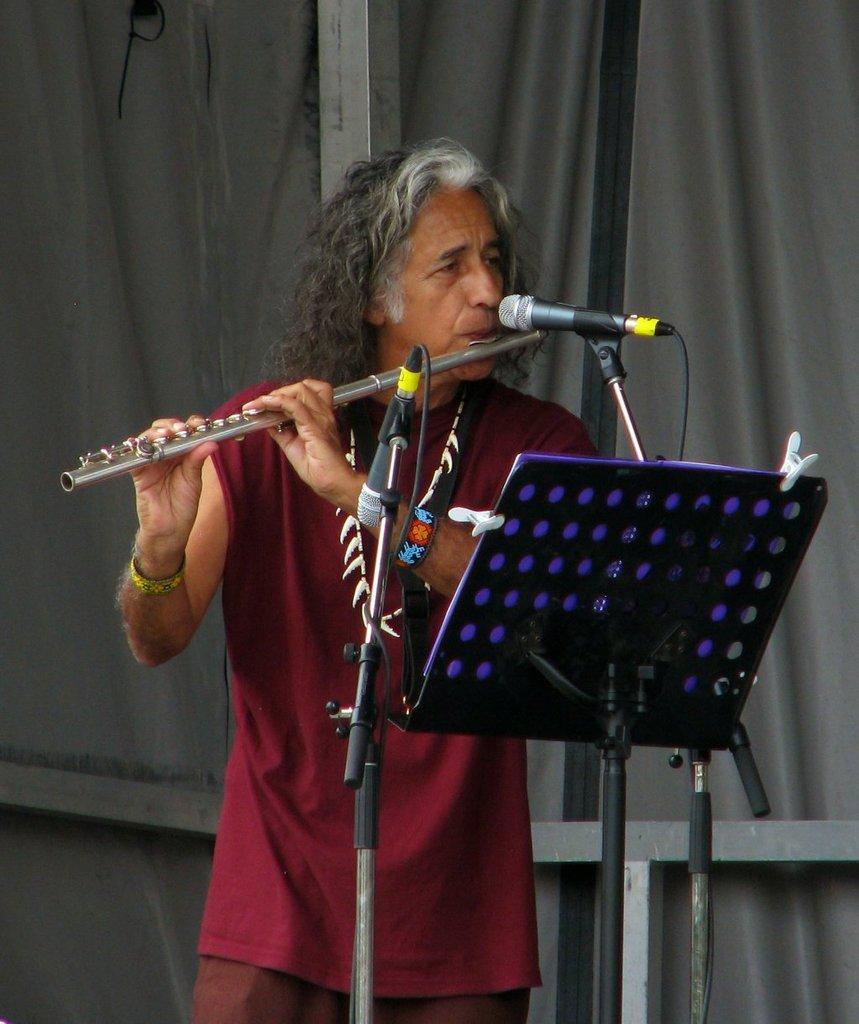Can you describe this image briefly? In this image we can see a person playing flute. In front of him there are mics with mic stands. Also there is a music note stand. In the back there is curtain. Also there are rods. 